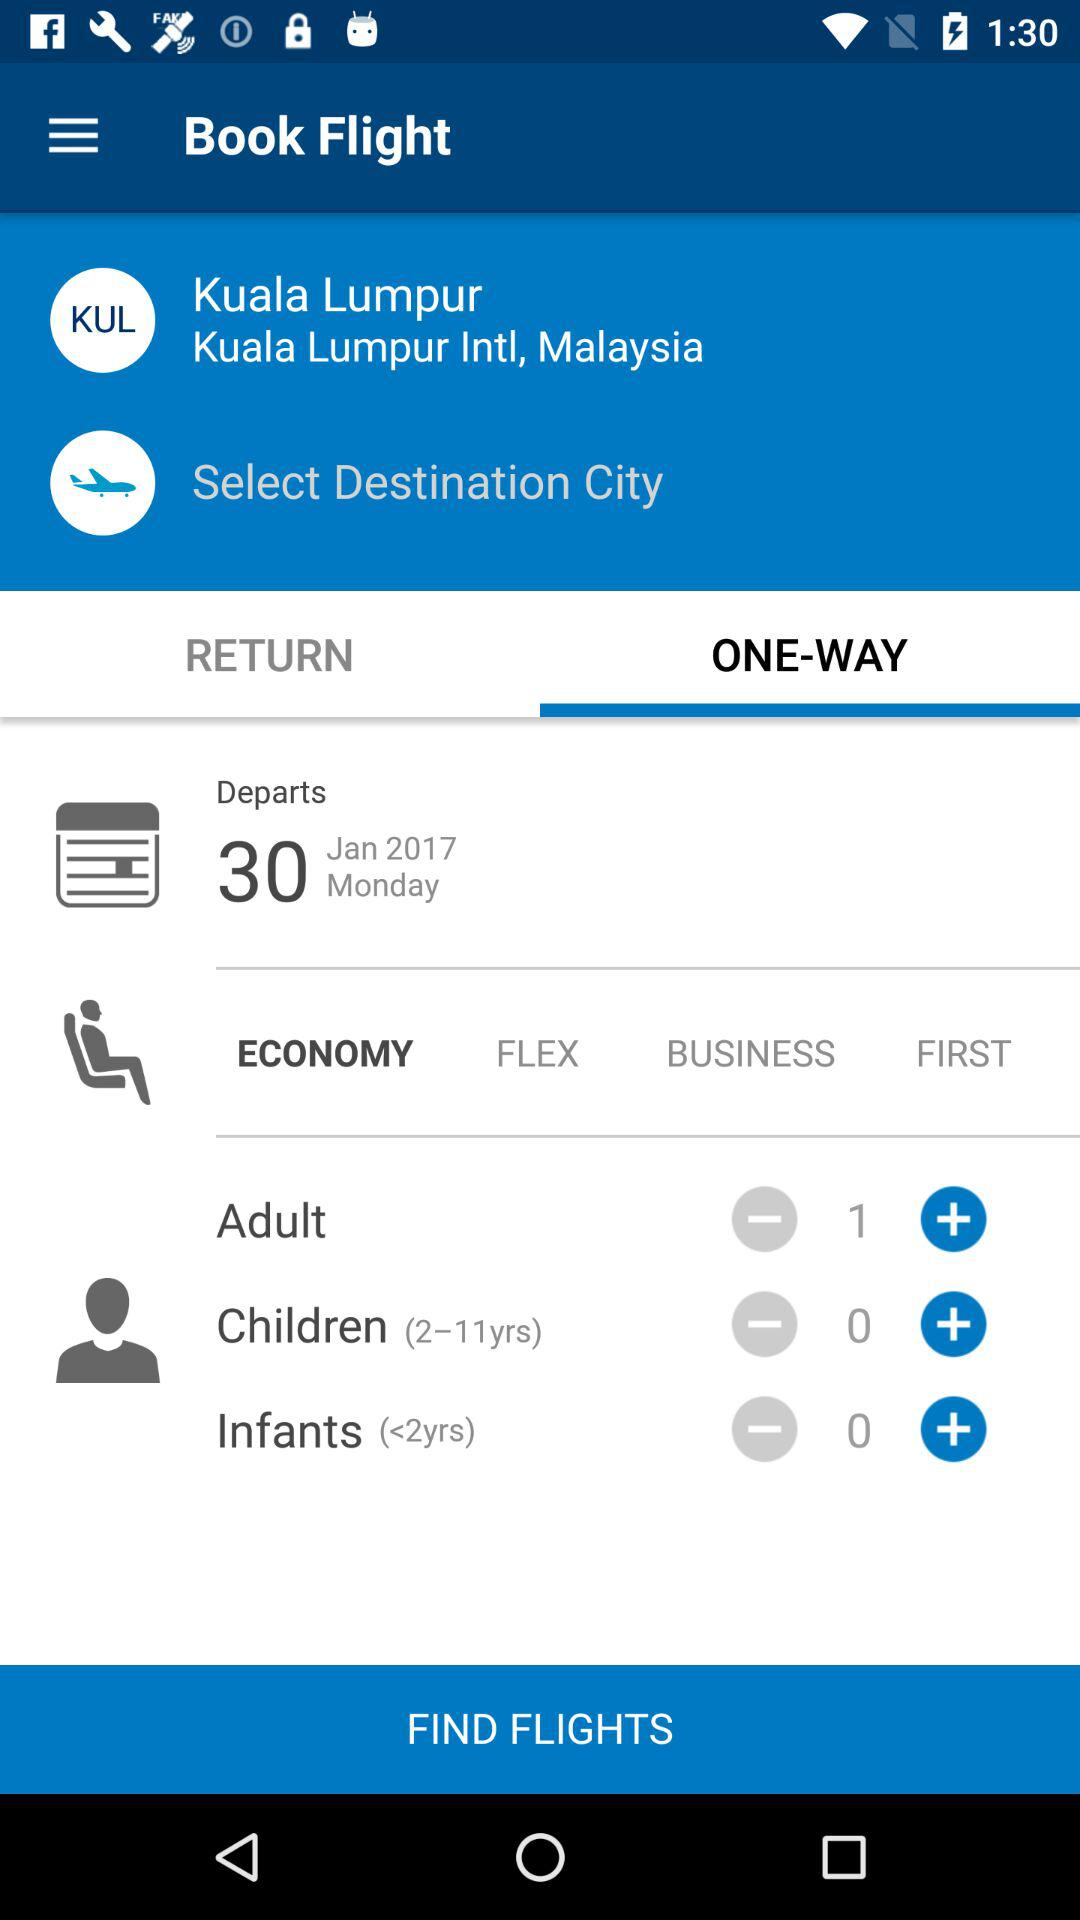How many different types of ticket classes are there?
Answer the question using a single word or phrase. 4 